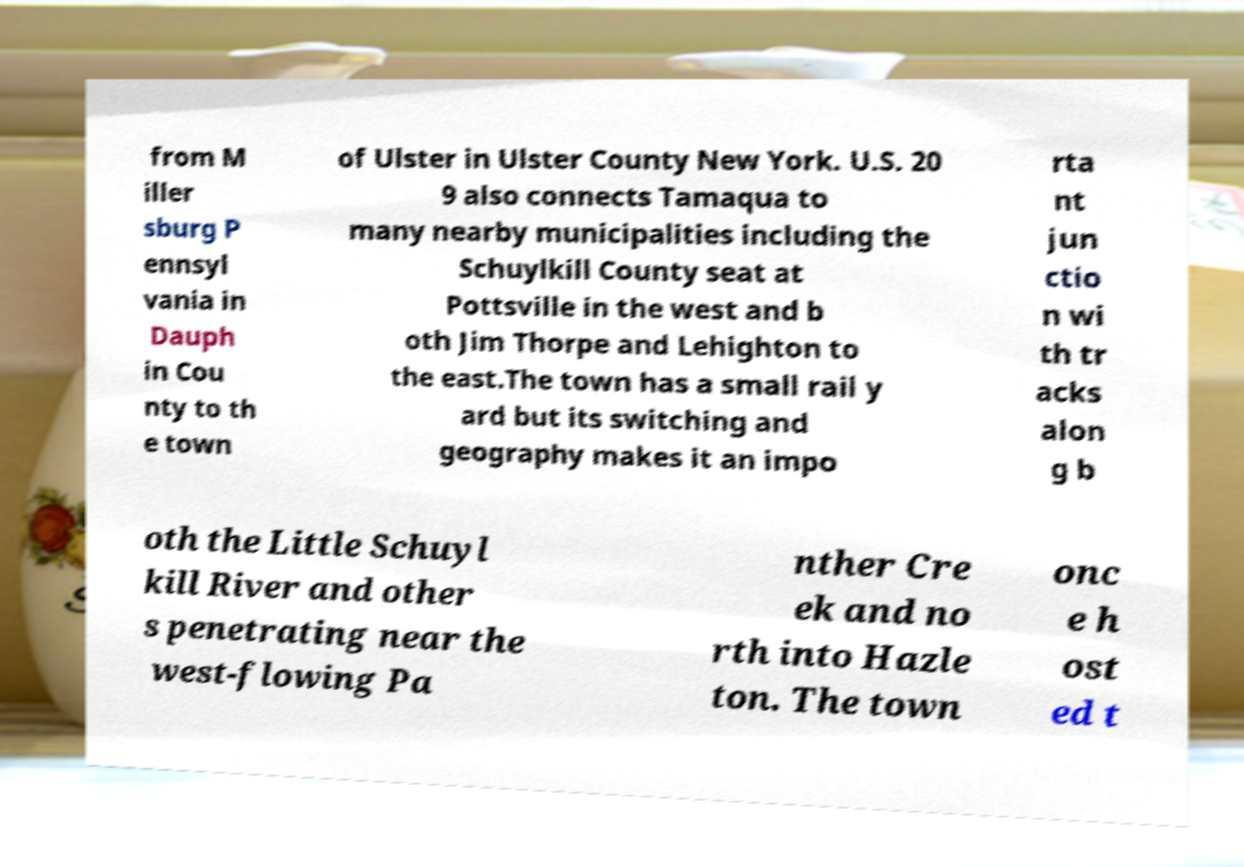Can you read and provide the text displayed in the image?This photo seems to have some interesting text. Can you extract and type it out for me? from M iller sburg P ennsyl vania in Dauph in Cou nty to th e town of Ulster in Ulster County New York. U.S. 20 9 also connects Tamaqua to many nearby municipalities including the Schuylkill County seat at Pottsville in the west and b oth Jim Thorpe and Lehighton to the east.The town has a small rail y ard but its switching and geography makes it an impo rta nt jun ctio n wi th tr acks alon g b oth the Little Schuyl kill River and other s penetrating near the west-flowing Pa nther Cre ek and no rth into Hazle ton. The town onc e h ost ed t 